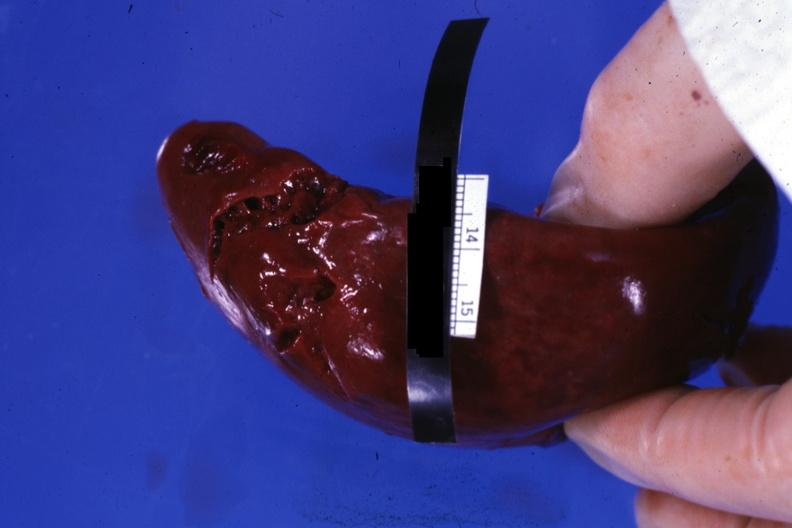when does this image show external view of lacerations of capsule apparently done?
Answer the question using a single word or phrase. During surgical procedure 